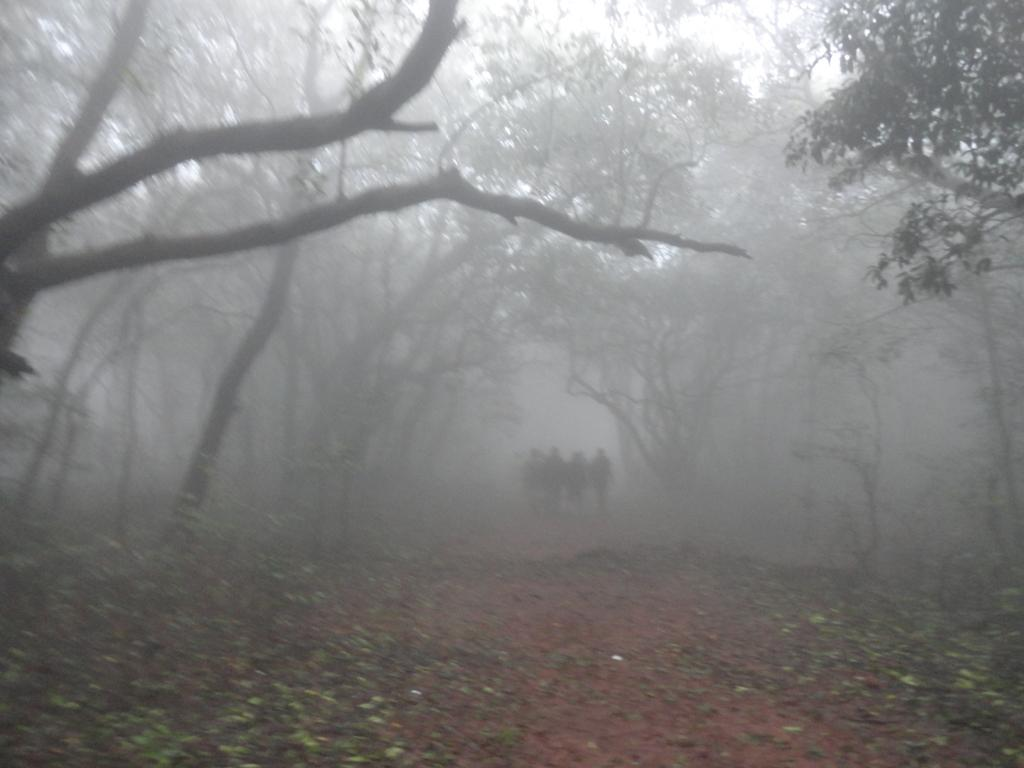What can be seen at the bottom of the image? There are people standing at the bottom of the image. What is located in the middle of the image? There are trees in the middle of the image. What is visible in the background of the image? The sky is visible in the background of the image. Can you tell me how many actors are present on the island in the image? There is no island or actors present in the image; it features people standing near trees with the sky visible in the background. What type of hose is being used by the people in the image? There is no hose present in the image. 